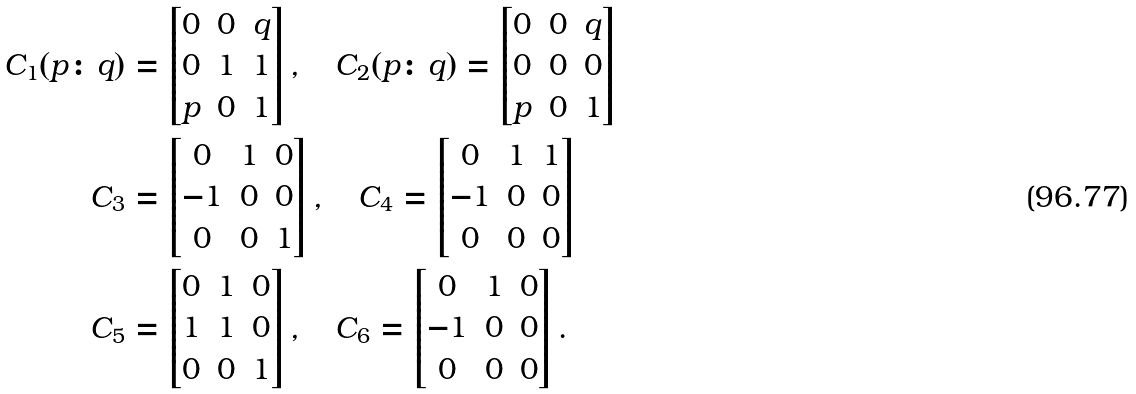<formula> <loc_0><loc_0><loc_500><loc_500>C _ { 1 } ( p \colon q ) & = \left [ \begin{matrix} 0 & 0 & q \\ 0 & 1 & 1 \\ p & 0 & 1 \end{matrix} \right ] , \quad C _ { 2 } ( p \colon q ) = \left [ \begin{matrix} 0 & 0 & q \\ 0 & 0 & 0 \\ p & 0 & 1 \end{matrix} \right ] \\ C _ { 3 } & = \left [ \begin{matrix} 0 & 1 & 0 \\ - 1 & 0 & 0 \\ 0 & 0 & 1 \end{matrix} \right ] , \quad C _ { 4 } = \left [ \begin{matrix} 0 & 1 & 1 \\ - 1 & 0 & 0 \\ 0 & 0 & 0 \end{matrix} \right ] \\ C _ { 5 } & = \left [ \begin{matrix} 0 & 1 & 0 \\ 1 & 1 & 0 \\ 0 & 0 & 1 \end{matrix} \right ] , \quad C _ { 6 } = \left [ \begin{matrix} 0 & 1 & 0 \\ - 1 & 0 & 0 \\ 0 & 0 & 0 \end{matrix} \right ] .</formula> 